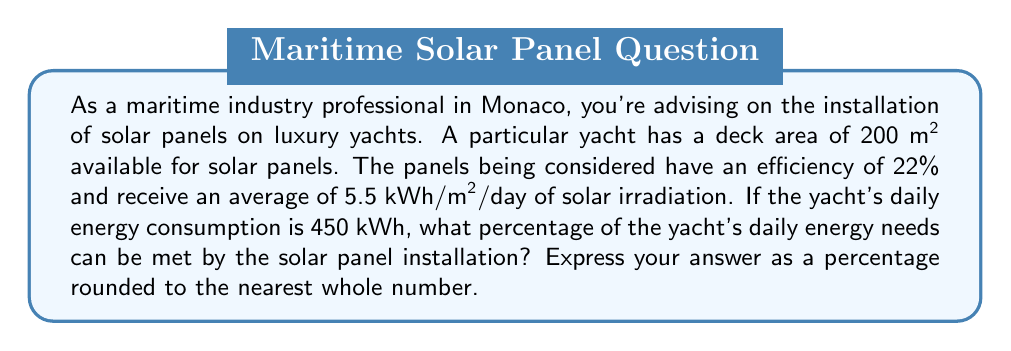Could you help me with this problem? Let's approach this problem step-by-step:

1) First, we need to calculate the total energy received by the solar panels per day:
   $$\text{Total energy received} = \text{Area} \times \text{Solar irradiation}$$
   $$\text{Total energy received} = 200 \text{ m}^2 \times 5.5 \text{ kWh/m}^2\text{/day} = 1100 \text{ kWh/day}$$

2) Now, we need to consider the efficiency of the solar panels:
   $$\text{Energy generated} = \text{Total energy received} \times \text{Efficiency}$$
   $$\text{Energy generated} = 1100 \text{ kWh/day} \times 0.22 = 242 \text{ kWh/day}$$

3) To find the percentage of the yacht's daily energy needs that can be met, we divide the energy generated by the solar panels by the yacht's daily energy consumption:
   $$\text{Percentage} = \frac{\text{Energy generated}}{\text{Daily energy consumption}} \times 100\%$$
   $$\text{Percentage} = \frac{242 \text{ kWh/day}}{450 \text{ kWh/day}} \times 100\% = 53.78\%$$

4) Rounding to the nearest whole number:
   $$53.78\% \approx 54\%$$
Answer: 54% 